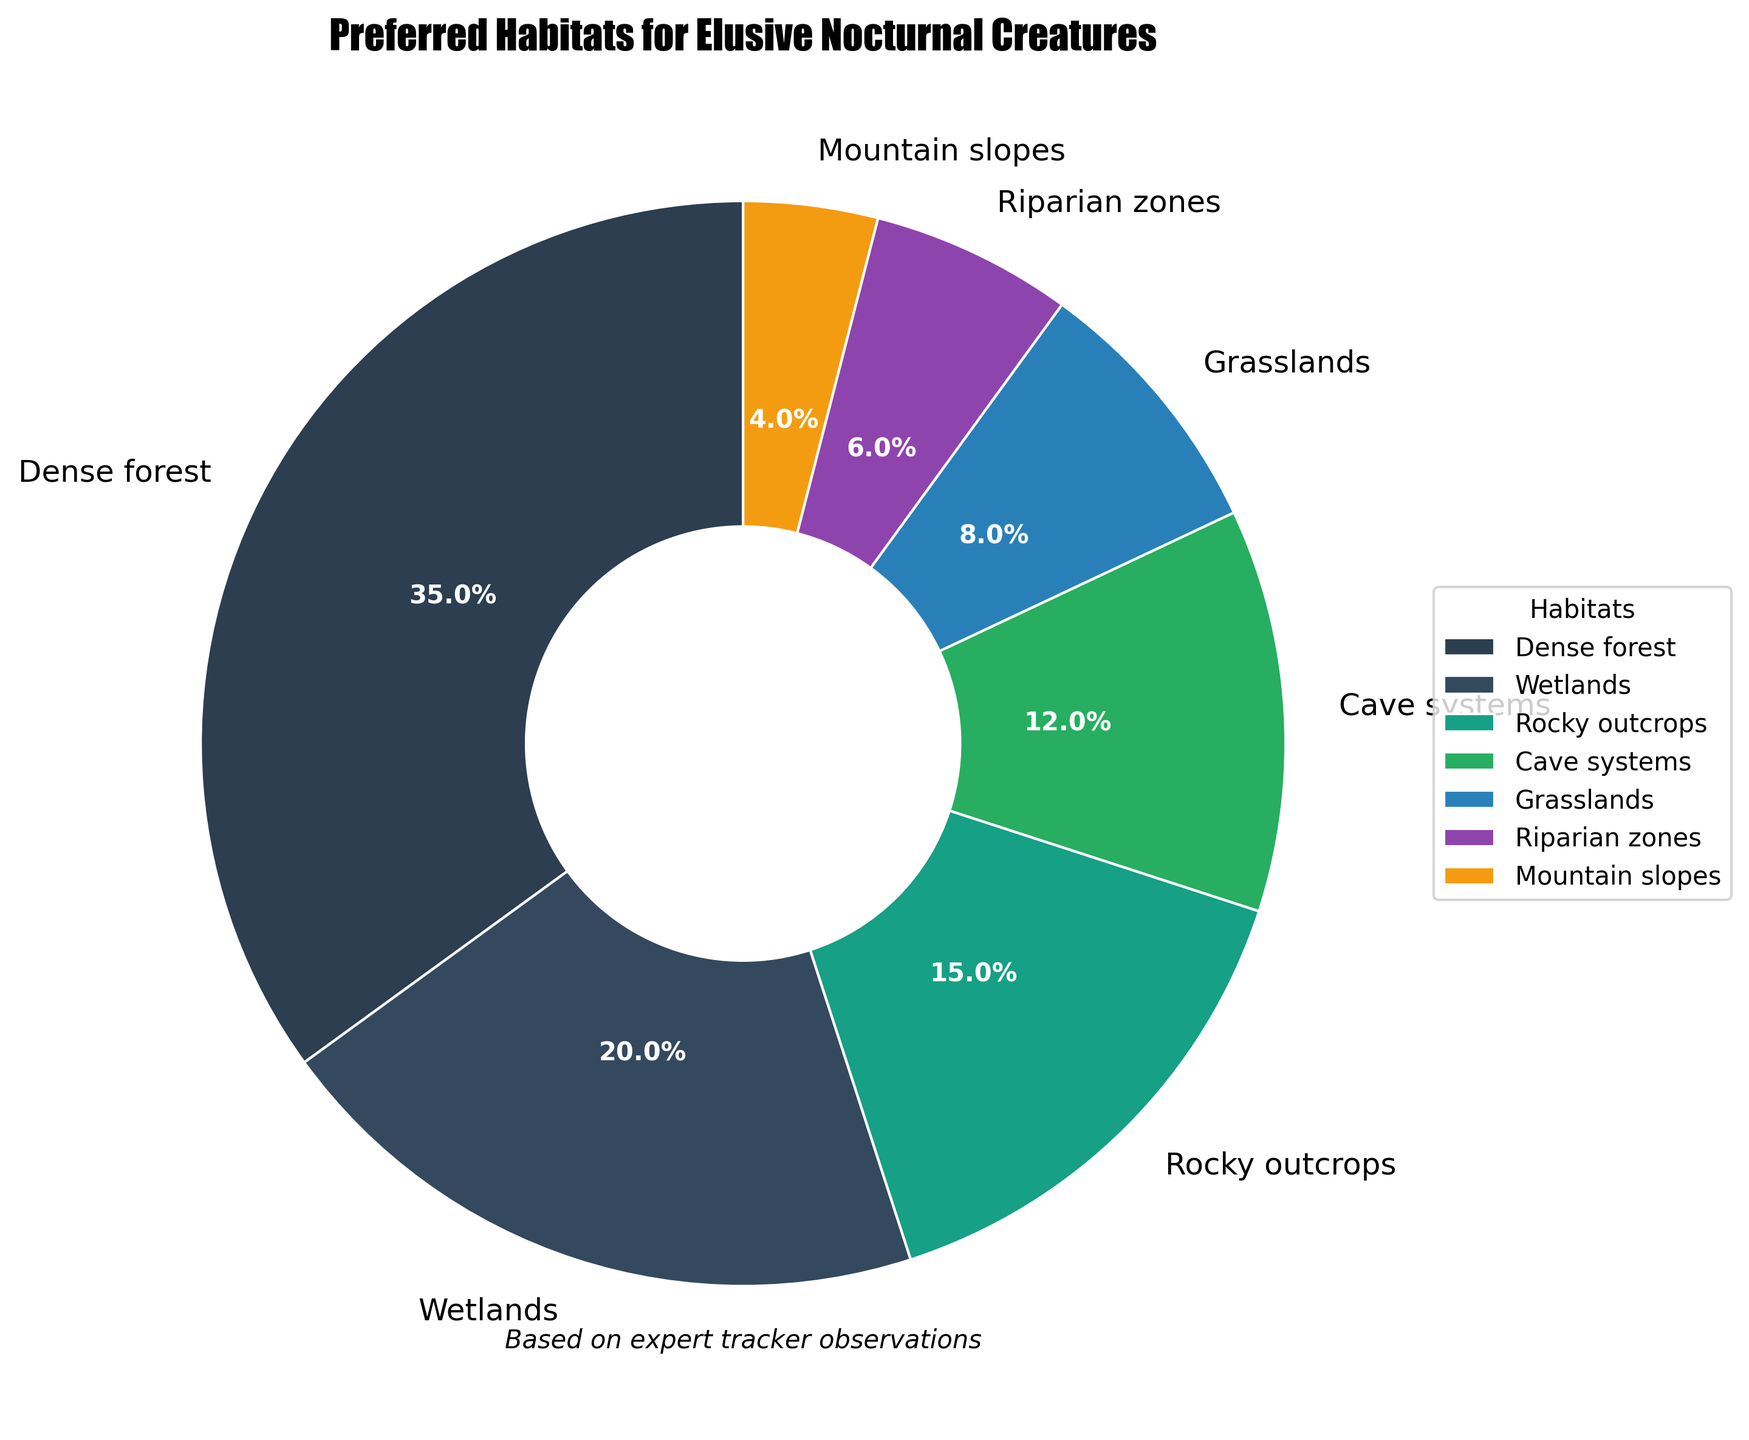What is the percentage of the least preferred habitat? The least preferred habitat is "Mountain slopes" as its slice is the smallest. According to the chart, it is 4%.
Answer: 4% Which habitat is more preferred, Cave systems or Rocky outcrops, and by how much? Comparing the percentages, Cave systems have 12% and Rocky outcrops have 15%. Hence, Rocky outcrops are more preferred by a difference of 15% - 12% = 3%.
Answer: Rocky outcrops, by 3% What percentage of creatures prefers either Dense forest or Wetlands? Sum up the percentages of Dense forest (35%) and Wetlands (20%): 35% + 20% = 55%.
Answer: 55% Are the cumulative preferences for Cave systems, Grasslands, and Riparian zones greater than for Dense forest? By how much? Adding the percentages for Cave systems (12%), Grasslands (8%), and Riparian zones (6%): 12% + 8% + 6% = 26%. Dense forest alone is 35%. 35% - 26% = 9%, so Dense forest is greater by 9%.
Answer: No, by 9% Which habitat has the second highest preference and what is its percentage? From the chart, after Dense forest (35%), Wetlands have the next largest slice at 20%.
Answer: Wetlands, 20% How much more preferred is Grasslands compared to Mountain slopes? Grasslands have 8%, and Mountain slopes have 4%. The difference is 8% - 4% = 4%.
Answer: 4% Combine the preferences for Rocky outcrops and Wetlands. Is it over or under half of the total proportion? Adding the percentages for Rocky outcrops (15%) and Wetlands (20%): 15% + 20% = 35%, which is under half (50%) of the total proportion.
Answer: Under How many habitats have a preference percentage greater than 10%? Identifying slices with percentages greater than 10%: Dense forest (35%), Wetlands (20%), and Rocky outcrops (15%) are more than 10%, totaling 3 habitats.
Answer: 3 What proportion of creatures prefers habitats that are not Dense forest? Subtracting Dense forest's percentage from the total 100%: 100% - 35% = 65%.
Answer: 65% Identify the habitats with the smallest two preference percentages. The smallest percentages belong to Mountain slopes (4%) and Riparian zones (6%).
Answer: Mountain slopes and Riparian zones 